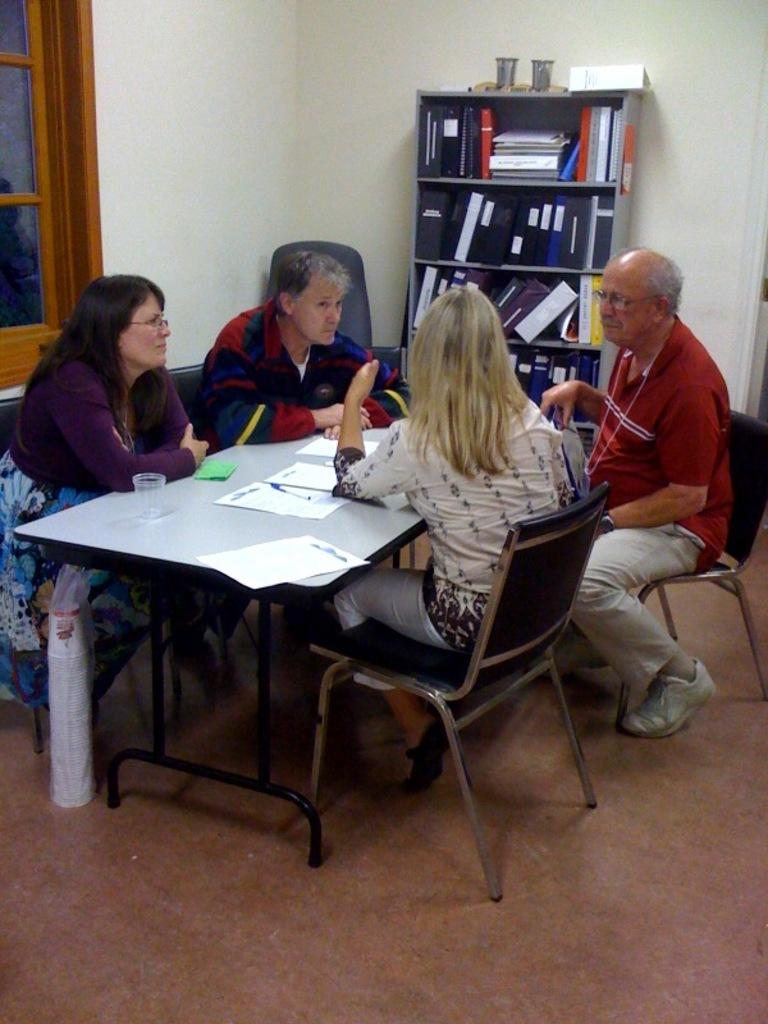What are the persons in the image doing? The persons in the image are sitting on chairs. What can be seen on the rack in the image? The rack is filled with files. What items are on the table in the image? There is a paper, pen, and glass on the table. Where are the paper cups located in the image? The paper cups are under the table. What is visible through the window in the image? There is a window in the image, but the facts do not specify what can be seen through it. Are there any ghosts visible in the image? There are no ghosts present in the image. What type of clouds can be seen through the window in the image? There is no information about clouds or the view through the window in the image. 